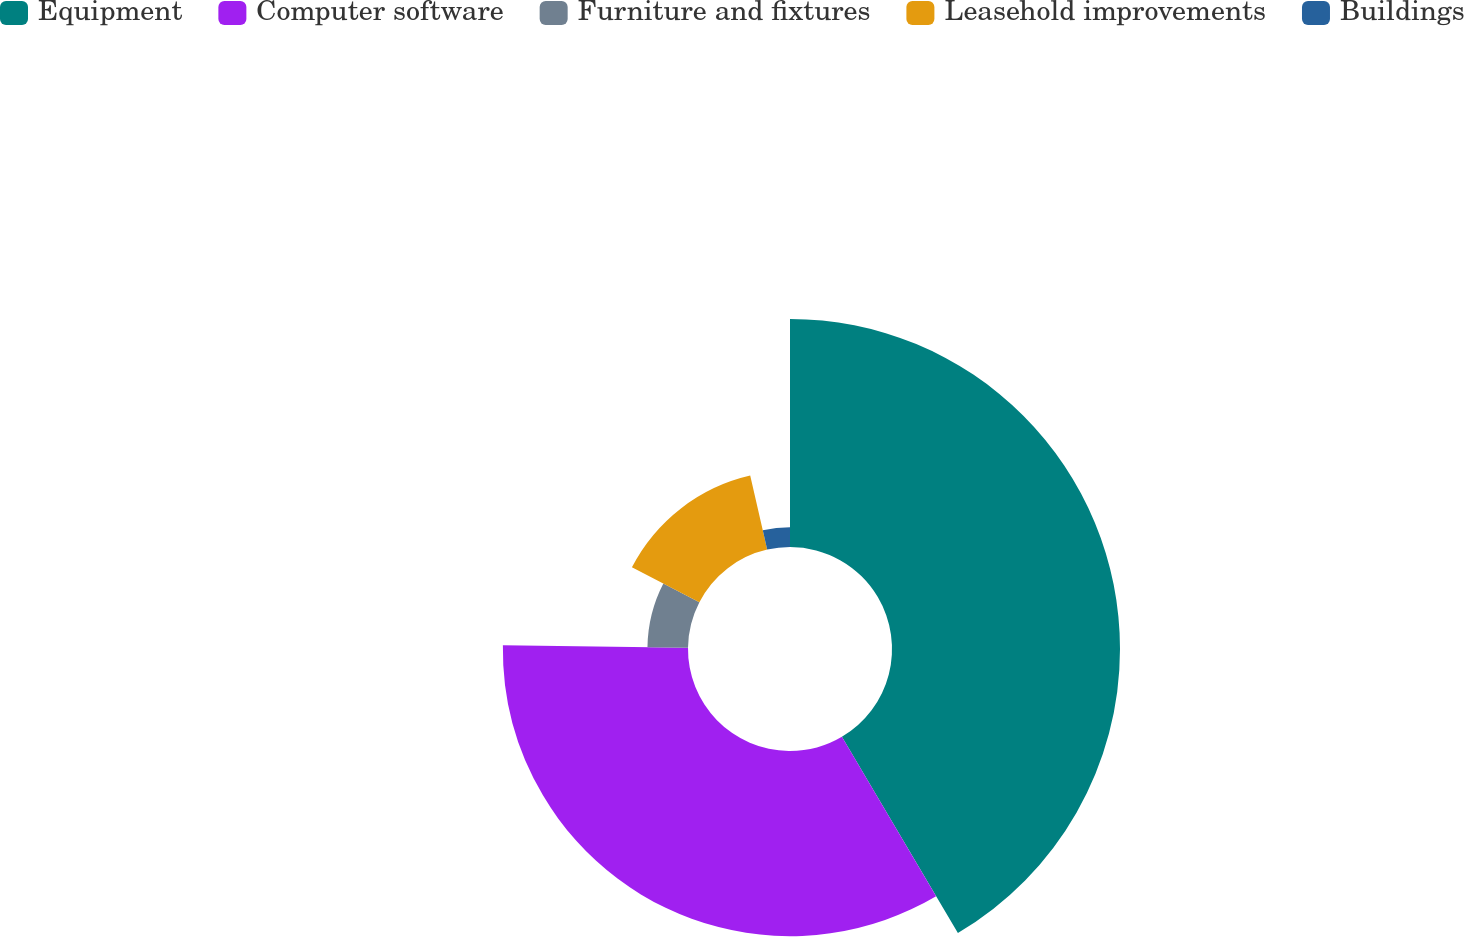Convert chart to OTSL. <chart><loc_0><loc_0><loc_500><loc_500><pie_chart><fcel>Equipment<fcel>Computer software<fcel>Furniture and fixtures<fcel>Leasehold improvements<fcel>Buildings<nl><fcel>41.5%<fcel>33.7%<fcel>7.38%<fcel>13.82%<fcel>3.59%<nl></chart> 